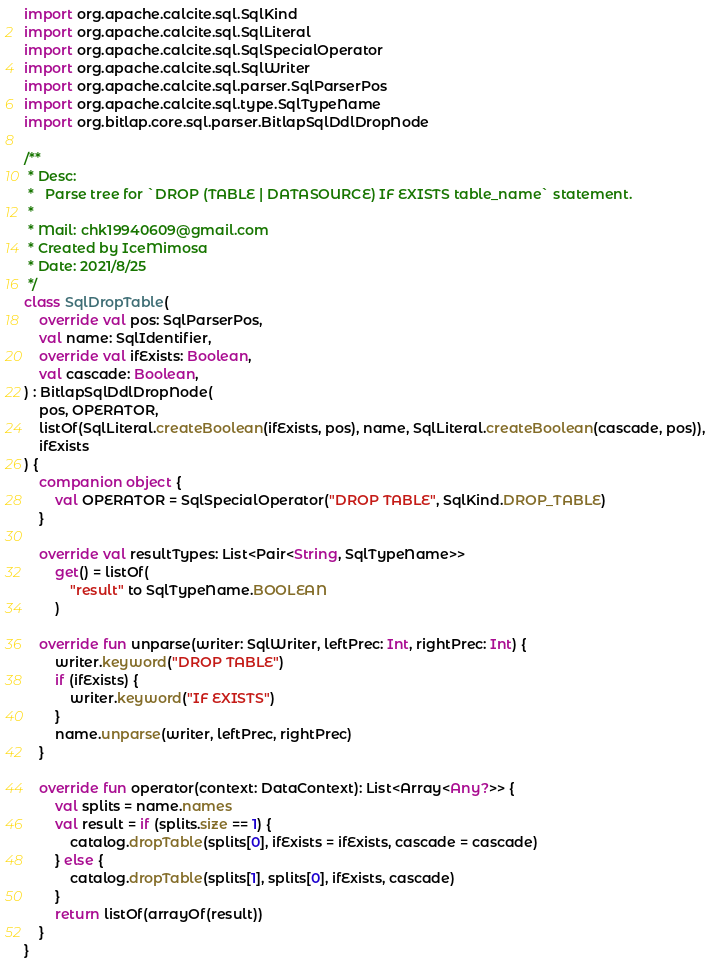<code> <loc_0><loc_0><loc_500><loc_500><_Kotlin_>import org.apache.calcite.sql.SqlKind
import org.apache.calcite.sql.SqlLiteral
import org.apache.calcite.sql.SqlSpecialOperator
import org.apache.calcite.sql.SqlWriter
import org.apache.calcite.sql.parser.SqlParserPos
import org.apache.calcite.sql.type.SqlTypeName
import org.bitlap.core.sql.parser.BitlapSqlDdlDropNode

/**
 * Desc:
 *   Parse tree for `DROP (TABLE | DATASOURCE) IF EXISTS table_name` statement.
 *
 * Mail: chk19940609@gmail.com
 * Created by IceMimosa
 * Date: 2021/8/25
 */
class SqlDropTable(
    override val pos: SqlParserPos,
    val name: SqlIdentifier,
    override val ifExists: Boolean,
    val cascade: Boolean,
) : BitlapSqlDdlDropNode(
    pos, OPERATOR,
    listOf(SqlLiteral.createBoolean(ifExists, pos), name, SqlLiteral.createBoolean(cascade, pos)),
    ifExists
) {
    companion object {
        val OPERATOR = SqlSpecialOperator("DROP TABLE", SqlKind.DROP_TABLE)
    }

    override val resultTypes: List<Pair<String, SqlTypeName>>
        get() = listOf(
            "result" to SqlTypeName.BOOLEAN
        )

    override fun unparse(writer: SqlWriter, leftPrec: Int, rightPrec: Int) {
        writer.keyword("DROP TABLE")
        if (ifExists) {
            writer.keyword("IF EXISTS")
        }
        name.unparse(writer, leftPrec, rightPrec)
    }

    override fun operator(context: DataContext): List<Array<Any?>> {
        val splits = name.names
        val result = if (splits.size == 1) {
            catalog.dropTable(splits[0], ifExists = ifExists, cascade = cascade)
        } else {
            catalog.dropTable(splits[1], splits[0], ifExists, cascade)
        }
        return listOf(arrayOf(result))
    }
}
</code> 